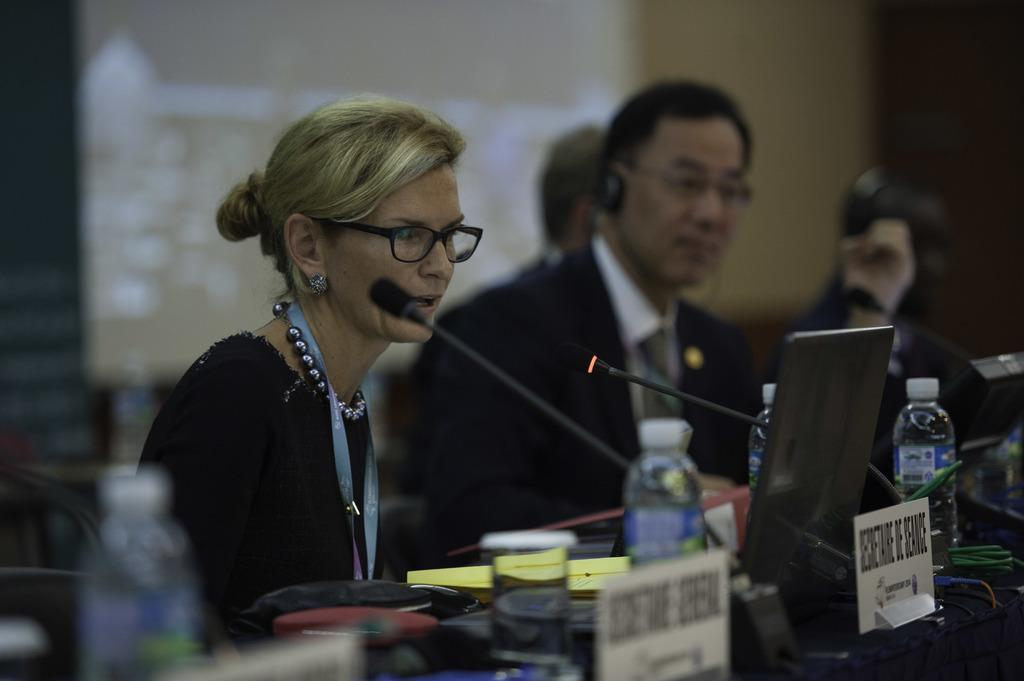How many people are in the image? There are two persons in the image. What are the persons doing in the image? The persons are sitting in front of microphones. What can be seen on the table in the image? There are bottles, boards, and a laptop on the table. What electronic device is present in the image? There is a laptop on the table. What is the condition of the background in the image? The background of the image is blurred. What is visible on the screen in the image? There is a screen visible in the image. What type of yarn is being used to create the map on the table? There is no yarn or map present on the table in the image. Where is the drawer located in the image? There is no drawer visible in the image. 